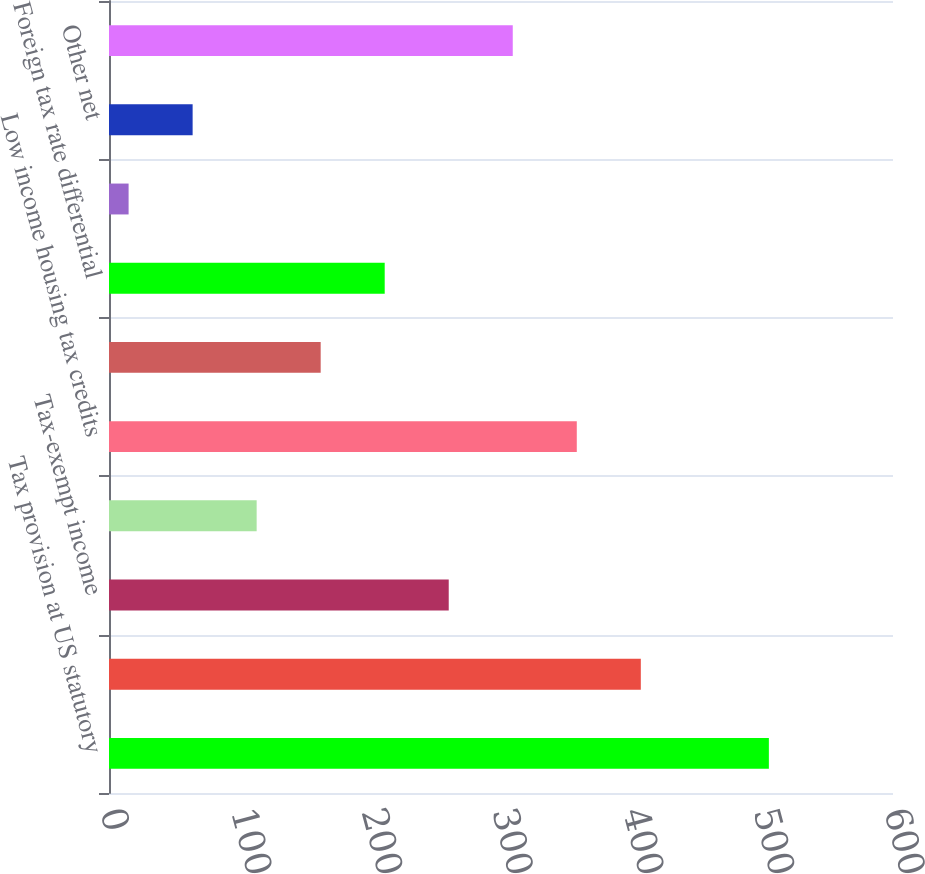<chart> <loc_0><loc_0><loc_500><loc_500><bar_chart><fcel>Tax provision at US statutory<fcel>Dividend received deduction<fcel>Tax-exempt income<fcel>Prior year tax<fcel>Low income housing tax credits<fcel>Other tax credits<fcel>Foreign tax rate differential<fcel>Change in valuation allowance<fcel>Other net<fcel>Provision for income tax<nl><fcel>505<fcel>407<fcel>260<fcel>113<fcel>358<fcel>162<fcel>211<fcel>15<fcel>64<fcel>309<nl></chart> 